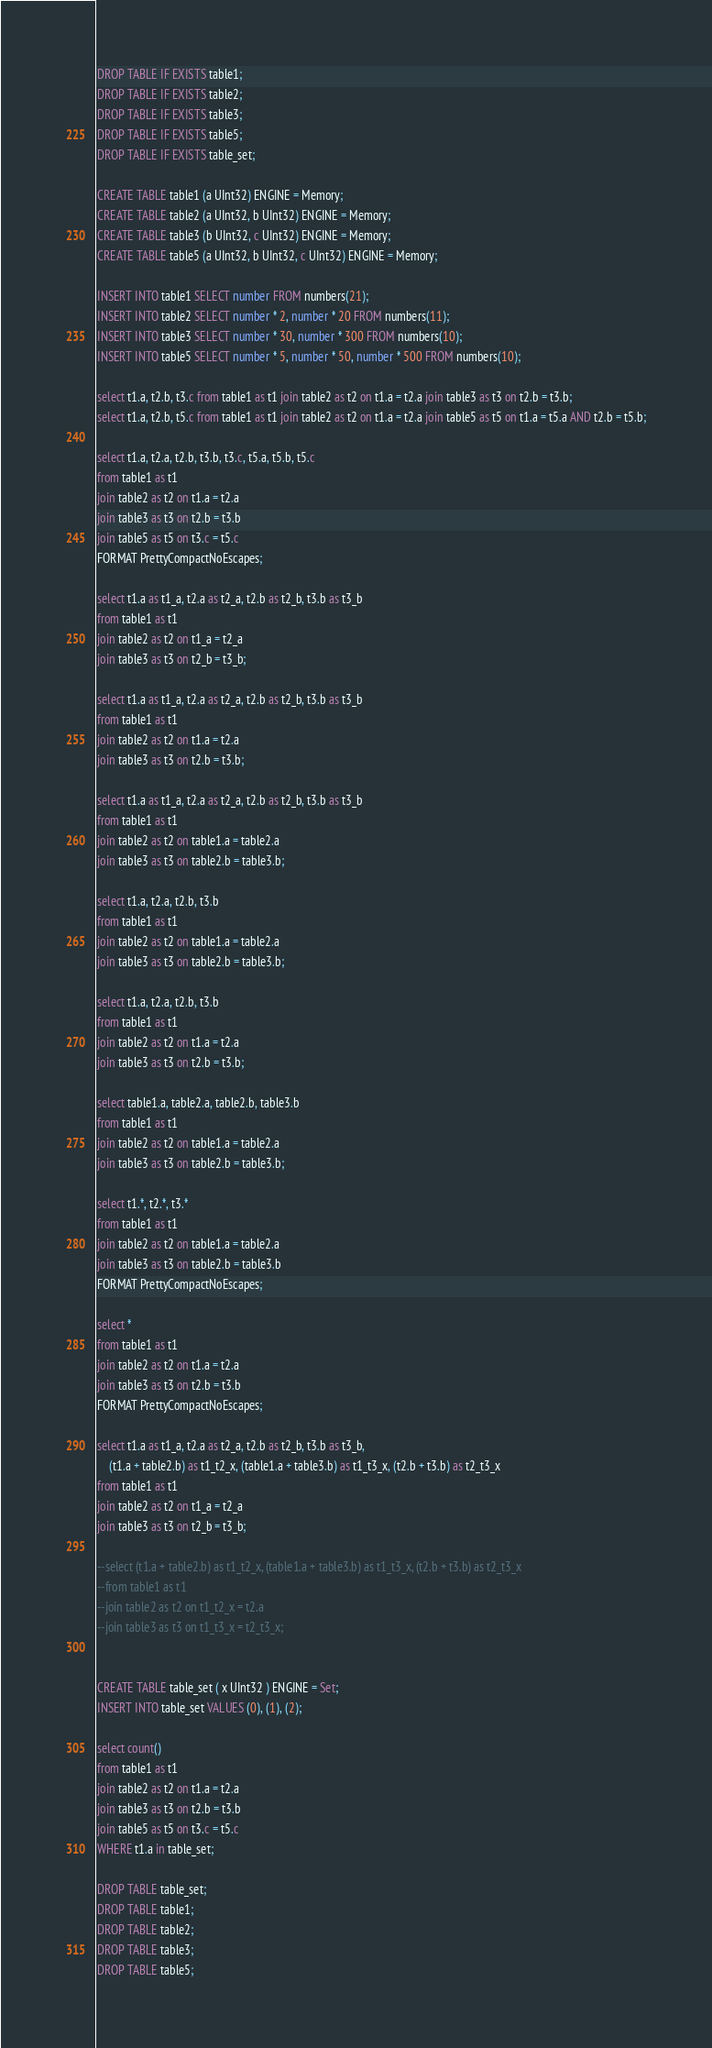Convert code to text. <code><loc_0><loc_0><loc_500><loc_500><_SQL_>DROP TABLE IF EXISTS table1;
DROP TABLE IF EXISTS table2;
DROP TABLE IF EXISTS table3;
DROP TABLE IF EXISTS table5;
DROP TABLE IF EXISTS table_set;

CREATE TABLE table1 (a UInt32) ENGINE = Memory;
CREATE TABLE table2 (a UInt32, b UInt32) ENGINE = Memory;
CREATE TABLE table3 (b UInt32, c UInt32) ENGINE = Memory;
CREATE TABLE table5 (a UInt32, b UInt32, c UInt32) ENGINE = Memory;

INSERT INTO table1 SELECT number FROM numbers(21);
INSERT INTO table2 SELECT number * 2, number * 20 FROM numbers(11);
INSERT INTO table3 SELECT number * 30, number * 300 FROM numbers(10);
INSERT INTO table5 SELECT number * 5, number * 50, number * 500 FROM numbers(10);

select t1.a, t2.b, t3.c from table1 as t1 join table2 as t2 on t1.a = t2.a join table3 as t3 on t2.b = t3.b;
select t1.a, t2.b, t5.c from table1 as t1 join table2 as t2 on t1.a = t2.a join table5 as t5 on t1.a = t5.a AND t2.b = t5.b;

select t1.a, t2.a, t2.b, t3.b, t3.c, t5.a, t5.b, t5.c
from table1 as t1
join table2 as t2 on t1.a = t2.a
join table3 as t3 on t2.b = t3.b
join table5 as t5 on t3.c = t5.c
FORMAT PrettyCompactNoEscapes;

select t1.a as t1_a, t2.a as t2_a, t2.b as t2_b, t3.b as t3_b
from table1 as t1
join table2 as t2 on t1_a = t2_a
join table3 as t3 on t2_b = t3_b;

select t1.a as t1_a, t2.a as t2_a, t2.b as t2_b, t3.b as t3_b
from table1 as t1
join table2 as t2 on t1.a = t2.a
join table3 as t3 on t2.b = t3.b;

select t1.a as t1_a, t2.a as t2_a, t2.b as t2_b, t3.b as t3_b
from table1 as t1
join table2 as t2 on table1.a = table2.a
join table3 as t3 on table2.b = table3.b;

select t1.a, t2.a, t2.b, t3.b
from table1 as t1
join table2 as t2 on table1.a = table2.a
join table3 as t3 on table2.b = table3.b;

select t1.a, t2.a, t2.b, t3.b
from table1 as t1
join table2 as t2 on t1.a = t2.a
join table3 as t3 on t2.b = t3.b;

select table1.a, table2.a, table2.b, table3.b
from table1 as t1
join table2 as t2 on table1.a = table2.a
join table3 as t3 on table2.b = table3.b;

select t1.*, t2.*, t3.*
from table1 as t1
join table2 as t2 on table1.a = table2.a
join table3 as t3 on table2.b = table3.b
FORMAT PrettyCompactNoEscapes;

select *
from table1 as t1
join table2 as t2 on t1.a = t2.a
join table3 as t3 on t2.b = t3.b
FORMAT PrettyCompactNoEscapes;

select t1.a as t1_a, t2.a as t2_a, t2.b as t2_b, t3.b as t3_b,
    (t1.a + table2.b) as t1_t2_x, (table1.a + table3.b) as t1_t3_x, (t2.b + t3.b) as t2_t3_x
from table1 as t1
join table2 as t2 on t1_a = t2_a
join table3 as t3 on t2_b = t3_b;

--select (t1.a + table2.b) as t1_t2_x, (table1.a + table3.b) as t1_t3_x, (t2.b + t3.b) as t2_t3_x
--from table1 as t1
--join table2 as t2 on t1_t2_x = t2.a
--join table3 as t3 on t1_t3_x = t2_t3_x;


CREATE TABLE table_set ( x UInt32 ) ENGINE = Set;
INSERT INTO table_set VALUES (0), (1), (2);

select count()
from table1 as t1
join table2 as t2 on t1.a = t2.a
join table3 as t3 on t2.b = t3.b
join table5 as t5 on t3.c = t5.c
WHERE t1.a in table_set;

DROP TABLE table_set;
DROP TABLE table1;
DROP TABLE table2;
DROP TABLE table3;
DROP TABLE table5;
</code> 